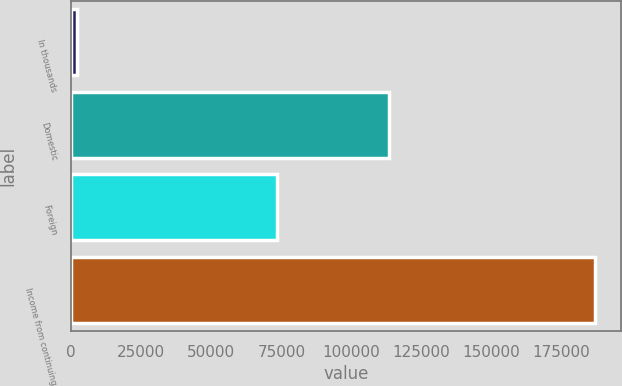<chart> <loc_0><loc_0><loc_500><loc_500><bar_chart><fcel>In thousands<fcel>Domestic<fcel>Foreign<fcel>Income from continuing<nl><fcel>2010<fcel>113430<fcel>73397<fcel>186827<nl></chart> 